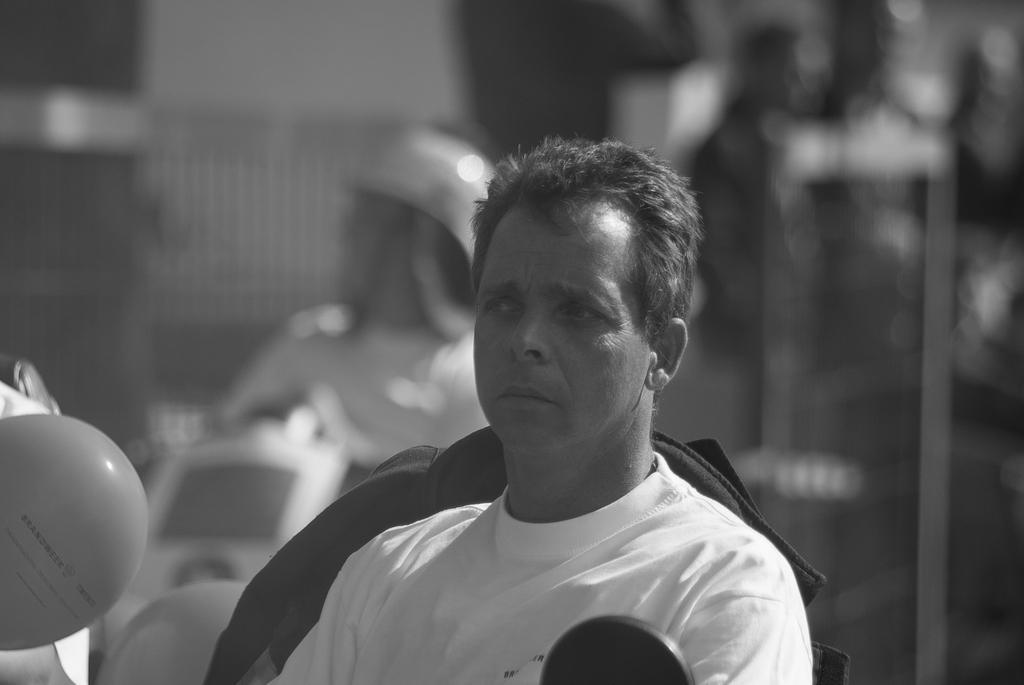Can you describe this image briefly? In the middle of the image a person is sitting. Behind him few people are sitting. Background of the image is blur. 